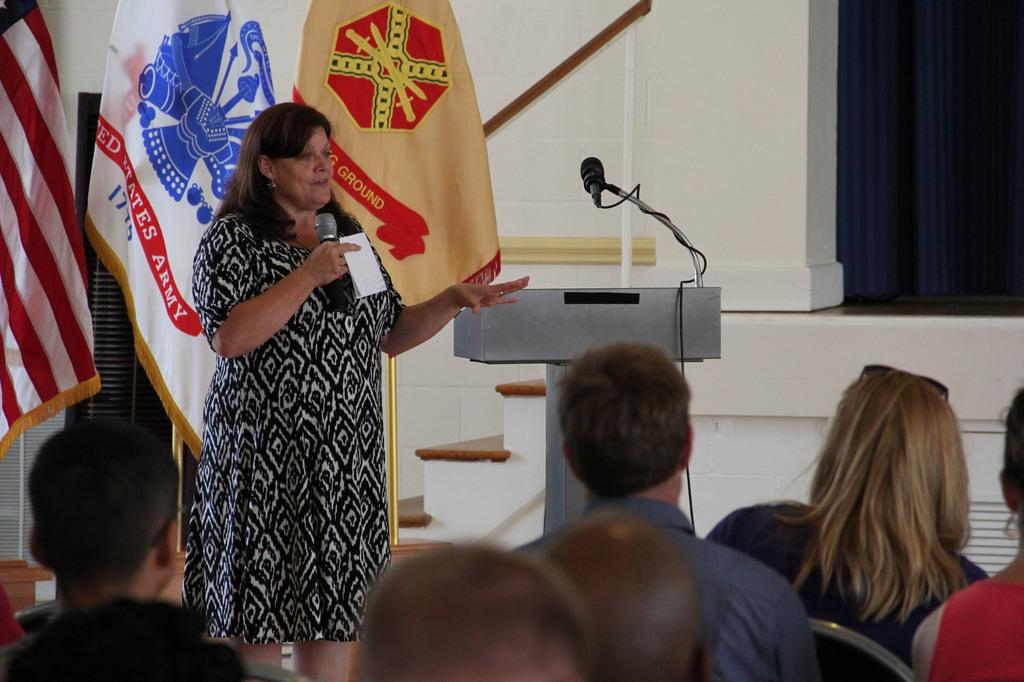Who is the main subject in the image? There is a woman in the image. What is the woman holding in her hand? The woman is holding a microphone (mike) in her hand. What are the people in the image doing? There are people sitting on chairs in the image. What other object related to the woman holding the microphone can be seen in the image? There is another microphone (mike) in the image. What symbol or emblem is present in the image? There is a flag in the image. What type of soup is being served to the beggar in the image? There is no beggar or soup present in the image. How does the sleet affect the people sitting on chairs in the image? There is no mention of sleet in the image, so its effect on the people cannot be determined. 